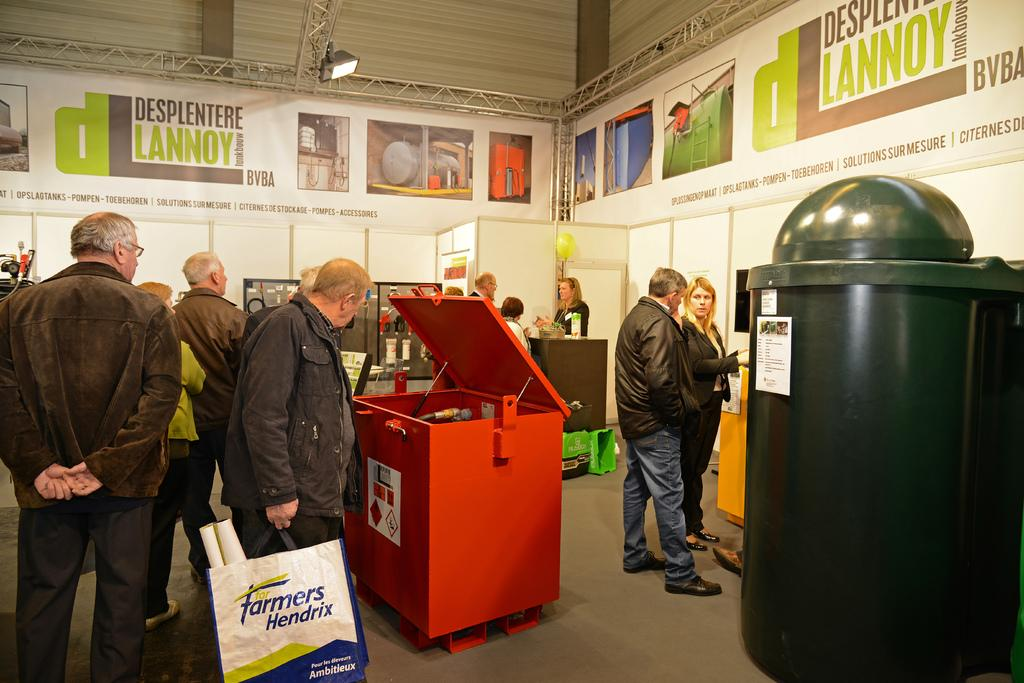<image>
Render a clear and concise summary of the photo. man holding a bag which says "Farmers Hendrix" on it. 